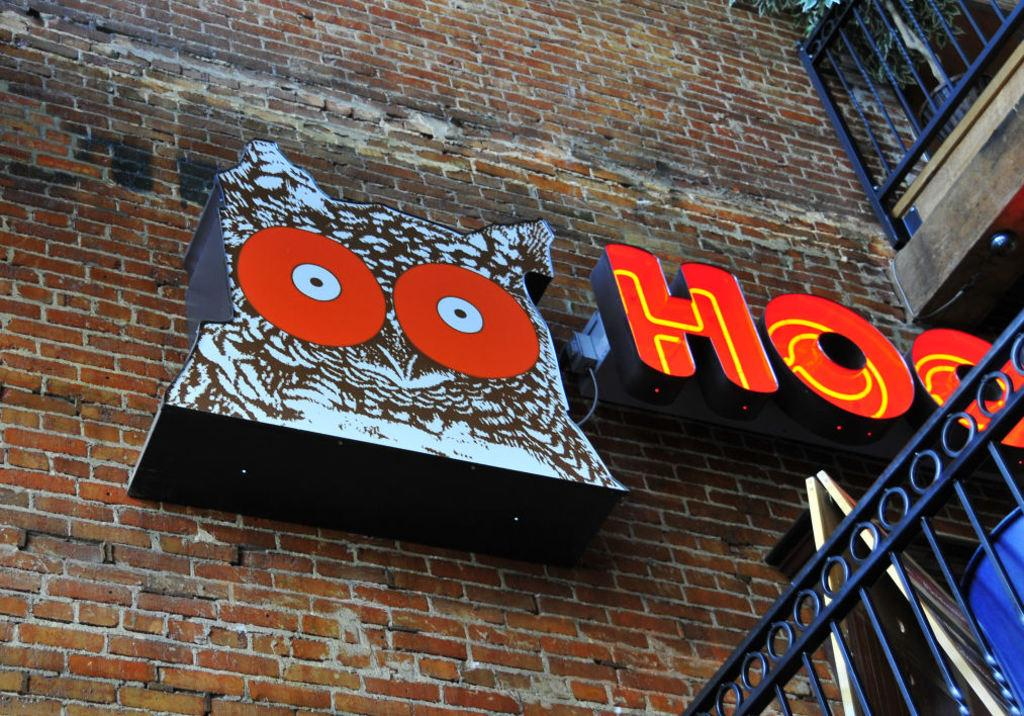<image>
Write a terse but informative summary of the picture. An image of an owl is on a brick wall next to the letters HOO. 